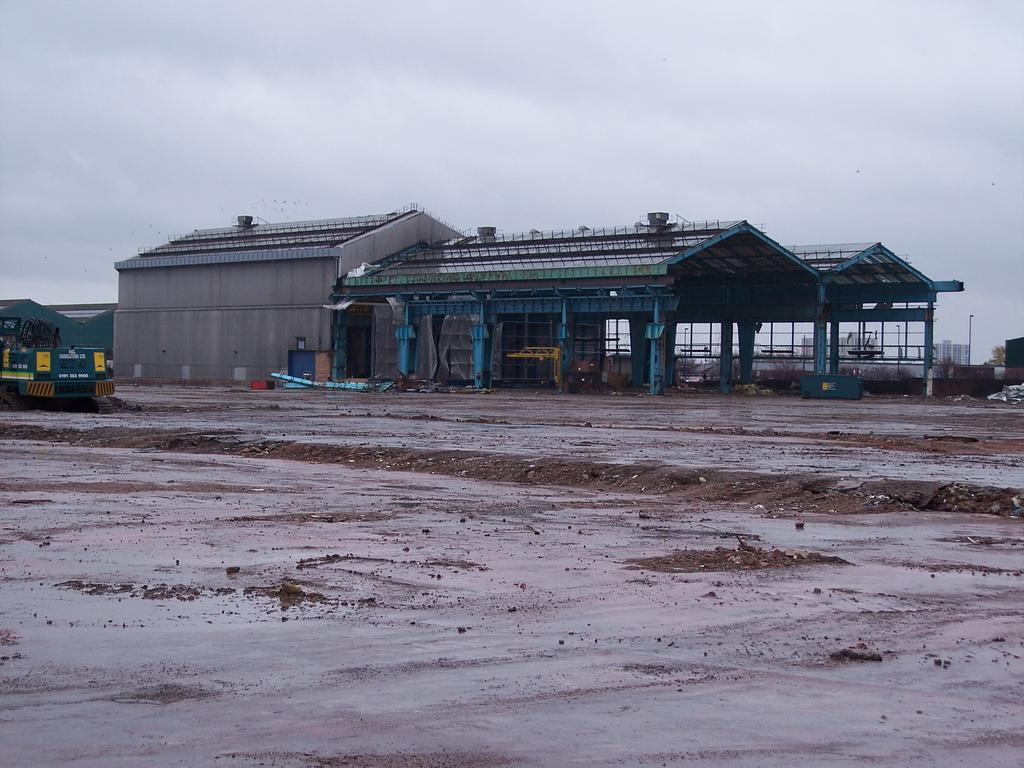Could you give a brief overview of what you see in this image? We can see vehicle on surface and we can see shed. On the background we can see building,light on pole and sky. 